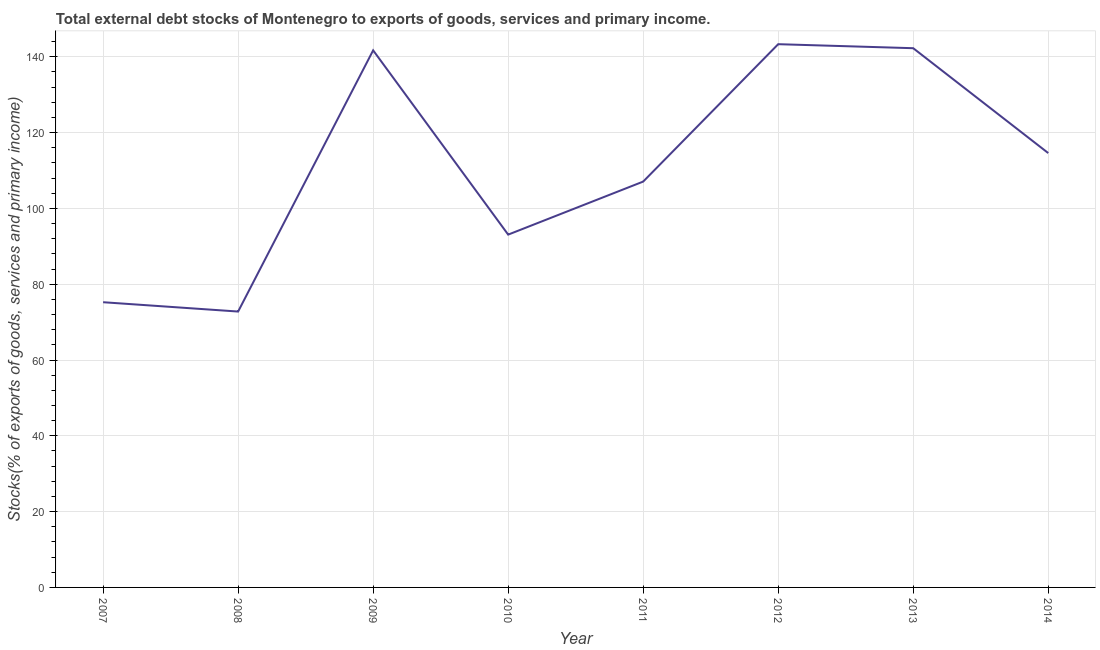What is the external debt stocks in 2014?
Make the answer very short. 114.6. Across all years, what is the maximum external debt stocks?
Your response must be concise. 143.33. Across all years, what is the minimum external debt stocks?
Provide a short and direct response. 72.79. In which year was the external debt stocks minimum?
Your answer should be very brief. 2008. What is the sum of the external debt stocks?
Offer a very short reply. 890.12. What is the difference between the external debt stocks in 2013 and 2014?
Your answer should be compact. 27.67. What is the average external debt stocks per year?
Your answer should be very brief. 111.26. What is the median external debt stocks?
Provide a succinct answer. 110.84. In how many years, is the external debt stocks greater than 36 %?
Provide a short and direct response. 8. What is the ratio of the external debt stocks in 2008 to that in 2010?
Provide a short and direct response. 0.78. Is the external debt stocks in 2011 less than that in 2014?
Offer a very short reply. Yes. Is the difference between the external debt stocks in 2007 and 2010 greater than the difference between any two years?
Provide a succinct answer. No. What is the difference between the highest and the second highest external debt stocks?
Keep it short and to the point. 1.06. Is the sum of the external debt stocks in 2008 and 2014 greater than the maximum external debt stocks across all years?
Your answer should be very brief. Yes. What is the difference between the highest and the lowest external debt stocks?
Your answer should be very brief. 70.54. In how many years, is the external debt stocks greater than the average external debt stocks taken over all years?
Ensure brevity in your answer.  4. How many lines are there?
Offer a very short reply. 1. How many years are there in the graph?
Provide a short and direct response. 8. Does the graph contain any zero values?
Keep it short and to the point. No. What is the title of the graph?
Offer a very short reply. Total external debt stocks of Montenegro to exports of goods, services and primary income. What is the label or title of the X-axis?
Provide a succinct answer. Year. What is the label or title of the Y-axis?
Your answer should be very brief. Stocks(% of exports of goods, services and primary income). What is the Stocks(% of exports of goods, services and primary income) of 2007?
Make the answer very short. 75.25. What is the Stocks(% of exports of goods, services and primary income) of 2008?
Keep it short and to the point. 72.79. What is the Stocks(% of exports of goods, services and primary income) of 2009?
Give a very brief answer. 141.71. What is the Stocks(% of exports of goods, services and primary income) of 2010?
Your response must be concise. 93.09. What is the Stocks(% of exports of goods, services and primary income) in 2011?
Keep it short and to the point. 107.08. What is the Stocks(% of exports of goods, services and primary income) of 2012?
Offer a very short reply. 143.33. What is the Stocks(% of exports of goods, services and primary income) in 2013?
Provide a succinct answer. 142.27. What is the Stocks(% of exports of goods, services and primary income) of 2014?
Make the answer very short. 114.6. What is the difference between the Stocks(% of exports of goods, services and primary income) in 2007 and 2008?
Offer a terse response. 2.46. What is the difference between the Stocks(% of exports of goods, services and primary income) in 2007 and 2009?
Offer a very short reply. -66.45. What is the difference between the Stocks(% of exports of goods, services and primary income) in 2007 and 2010?
Provide a succinct answer. -17.84. What is the difference between the Stocks(% of exports of goods, services and primary income) in 2007 and 2011?
Offer a very short reply. -31.83. What is the difference between the Stocks(% of exports of goods, services and primary income) in 2007 and 2012?
Your answer should be compact. -68.08. What is the difference between the Stocks(% of exports of goods, services and primary income) in 2007 and 2013?
Offer a terse response. -67.02. What is the difference between the Stocks(% of exports of goods, services and primary income) in 2007 and 2014?
Your answer should be compact. -39.35. What is the difference between the Stocks(% of exports of goods, services and primary income) in 2008 and 2009?
Keep it short and to the point. -68.92. What is the difference between the Stocks(% of exports of goods, services and primary income) in 2008 and 2010?
Provide a short and direct response. -20.3. What is the difference between the Stocks(% of exports of goods, services and primary income) in 2008 and 2011?
Make the answer very short. -34.29. What is the difference between the Stocks(% of exports of goods, services and primary income) in 2008 and 2012?
Offer a very short reply. -70.54. What is the difference between the Stocks(% of exports of goods, services and primary income) in 2008 and 2013?
Offer a very short reply. -69.48. What is the difference between the Stocks(% of exports of goods, services and primary income) in 2008 and 2014?
Give a very brief answer. -41.81. What is the difference between the Stocks(% of exports of goods, services and primary income) in 2009 and 2010?
Make the answer very short. 48.62. What is the difference between the Stocks(% of exports of goods, services and primary income) in 2009 and 2011?
Offer a very short reply. 34.63. What is the difference between the Stocks(% of exports of goods, services and primary income) in 2009 and 2012?
Make the answer very short. -1.62. What is the difference between the Stocks(% of exports of goods, services and primary income) in 2009 and 2013?
Keep it short and to the point. -0.57. What is the difference between the Stocks(% of exports of goods, services and primary income) in 2009 and 2014?
Make the answer very short. 27.1. What is the difference between the Stocks(% of exports of goods, services and primary income) in 2010 and 2011?
Ensure brevity in your answer.  -13.99. What is the difference between the Stocks(% of exports of goods, services and primary income) in 2010 and 2012?
Offer a terse response. -50.24. What is the difference between the Stocks(% of exports of goods, services and primary income) in 2010 and 2013?
Provide a short and direct response. -49.18. What is the difference between the Stocks(% of exports of goods, services and primary income) in 2010 and 2014?
Keep it short and to the point. -21.52. What is the difference between the Stocks(% of exports of goods, services and primary income) in 2011 and 2012?
Your answer should be compact. -36.25. What is the difference between the Stocks(% of exports of goods, services and primary income) in 2011 and 2013?
Provide a short and direct response. -35.19. What is the difference between the Stocks(% of exports of goods, services and primary income) in 2011 and 2014?
Your answer should be very brief. -7.52. What is the difference between the Stocks(% of exports of goods, services and primary income) in 2012 and 2013?
Provide a succinct answer. 1.06. What is the difference between the Stocks(% of exports of goods, services and primary income) in 2012 and 2014?
Keep it short and to the point. 28.73. What is the difference between the Stocks(% of exports of goods, services and primary income) in 2013 and 2014?
Offer a terse response. 27.67. What is the ratio of the Stocks(% of exports of goods, services and primary income) in 2007 to that in 2008?
Give a very brief answer. 1.03. What is the ratio of the Stocks(% of exports of goods, services and primary income) in 2007 to that in 2009?
Offer a terse response. 0.53. What is the ratio of the Stocks(% of exports of goods, services and primary income) in 2007 to that in 2010?
Your answer should be very brief. 0.81. What is the ratio of the Stocks(% of exports of goods, services and primary income) in 2007 to that in 2011?
Your answer should be compact. 0.7. What is the ratio of the Stocks(% of exports of goods, services and primary income) in 2007 to that in 2012?
Offer a very short reply. 0.53. What is the ratio of the Stocks(% of exports of goods, services and primary income) in 2007 to that in 2013?
Make the answer very short. 0.53. What is the ratio of the Stocks(% of exports of goods, services and primary income) in 2007 to that in 2014?
Provide a short and direct response. 0.66. What is the ratio of the Stocks(% of exports of goods, services and primary income) in 2008 to that in 2009?
Make the answer very short. 0.51. What is the ratio of the Stocks(% of exports of goods, services and primary income) in 2008 to that in 2010?
Your answer should be very brief. 0.78. What is the ratio of the Stocks(% of exports of goods, services and primary income) in 2008 to that in 2011?
Your response must be concise. 0.68. What is the ratio of the Stocks(% of exports of goods, services and primary income) in 2008 to that in 2012?
Ensure brevity in your answer.  0.51. What is the ratio of the Stocks(% of exports of goods, services and primary income) in 2008 to that in 2013?
Your answer should be very brief. 0.51. What is the ratio of the Stocks(% of exports of goods, services and primary income) in 2008 to that in 2014?
Keep it short and to the point. 0.64. What is the ratio of the Stocks(% of exports of goods, services and primary income) in 2009 to that in 2010?
Give a very brief answer. 1.52. What is the ratio of the Stocks(% of exports of goods, services and primary income) in 2009 to that in 2011?
Ensure brevity in your answer.  1.32. What is the ratio of the Stocks(% of exports of goods, services and primary income) in 2009 to that in 2014?
Keep it short and to the point. 1.24. What is the ratio of the Stocks(% of exports of goods, services and primary income) in 2010 to that in 2011?
Offer a terse response. 0.87. What is the ratio of the Stocks(% of exports of goods, services and primary income) in 2010 to that in 2012?
Your answer should be compact. 0.65. What is the ratio of the Stocks(% of exports of goods, services and primary income) in 2010 to that in 2013?
Keep it short and to the point. 0.65. What is the ratio of the Stocks(% of exports of goods, services and primary income) in 2010 to that in 2014?
Offer a terse response. 0.81. What is the ratio of the Stocks(% of exports of goods, services and primary income) in 2011 to that in 2012?
Provide a short and direct response. 0.75. What is the ratio of the Stocks(% of exports of goods, services and primary income) in 2011 to that in 2013?
Give a very brief answer. 0.75. What is the ratio of the Stocks(% of exports of goods, services and primary income) in 2011 to that in 2014?
Offer a very short reply. 0.93. What is the ratio of the Stocks(% of exports of goods, services and primary income) in 2012 to that in 2014?
Provide a short and direct response. 1.25. What is the ratio of the Stocks(% of exports of goods, services and primary income) in 2013 to that in 2014?
Provide a short and direct response. 1.24. 